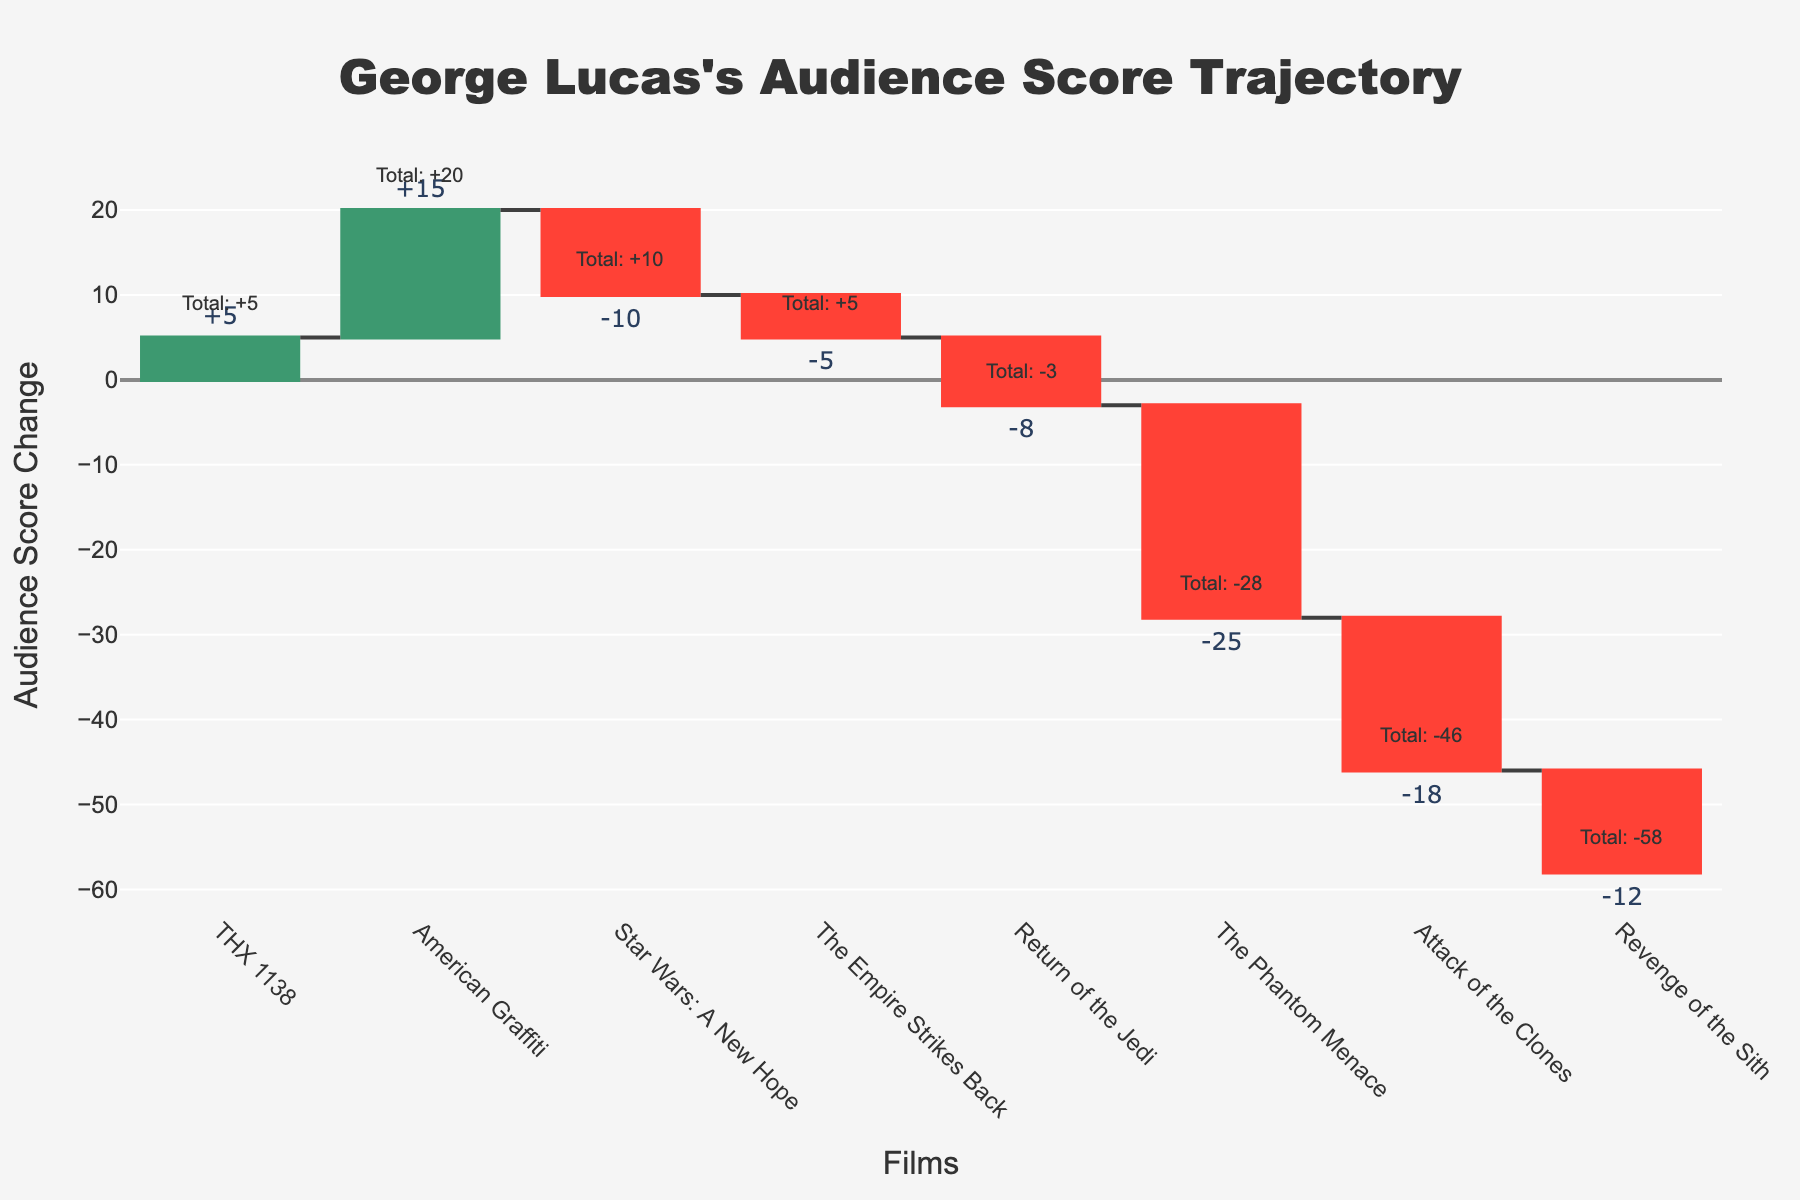What's the title of the waterfall chart? The title is prominently displayed at the top of the chart, indicating the overarching theme or subject of the visual representation.
Answer: George Lucas's Audience Score Trajectory Which film had the highest increase in audience score? Looking at the positive changes, the highest increase is associated with the film with the largest upward bar.
Answer: American Graffiti What was the audience score change for 'Revenge of the Sith'? Find the bar corresponding to 'Revenge of the Sith' and read the associated value.
Answer: -12 How many films had a decreasing audience score? Count the number of films with negative audience score changes by noting the downward bars.
Answer: 5 Which film marked the largest decline in audience score? Locate the film with the largest downward bar to identify the most significant decline.
Answer: The Phantom Menace What is the cumulative audience score change after 'The Empire Strikes Back'? Sum the changes for 'THX 1138', 'American Graffiti', 'Star Wars: A New Hope', and 'The Empire Strikes Back'. (+5) + (+15) + (-10) + (-5) = 5
Answer: 5 What is the cumulative audience score change for George Lucas's first four films? Include the scores of the first four films: (THX 1138, American Graffiti, Star Wars: A New Hope, The Empire Strikes Back). Calculate the sum: (+5) + (+15) + (-10) + (-5) = 5
Answer: 5 Which two films had a combined audience score change of -30? Examine the chart to find two downward bars whose sum equals -30. The films ‘The Phantom Menace’ (-25) and ‘Attack of the Clones’ (-18) combined fall short, suggesting other pairings. However, 'The Phantom Menace' (-25) and 'Return of the Jedi' (-8) also combined fall short. Neither combination observed exactly yields -30, suggesting a potential error in the formulation or intent. Re-calibration of values or analysis might be warranted.
Answer: (No such pair exactly, suggesting a reevaluation of question or chart values.) How does 'Return of the Jedi' compare to 'The Empire Strikes Back' in terms of audience score change? Compare the heights and directions of the bars corresponding to each film. 'Return of the Jedi' has a greater negative change than 'The Empire Strikes Back’.
Answer: 'Return of the Jedi' had a larger decline Which film resulted in the first overall negative cumulative score? Track the running tally along the cumulative score annotations until it goes negative.
Answer: Star Wars: A New Hope 